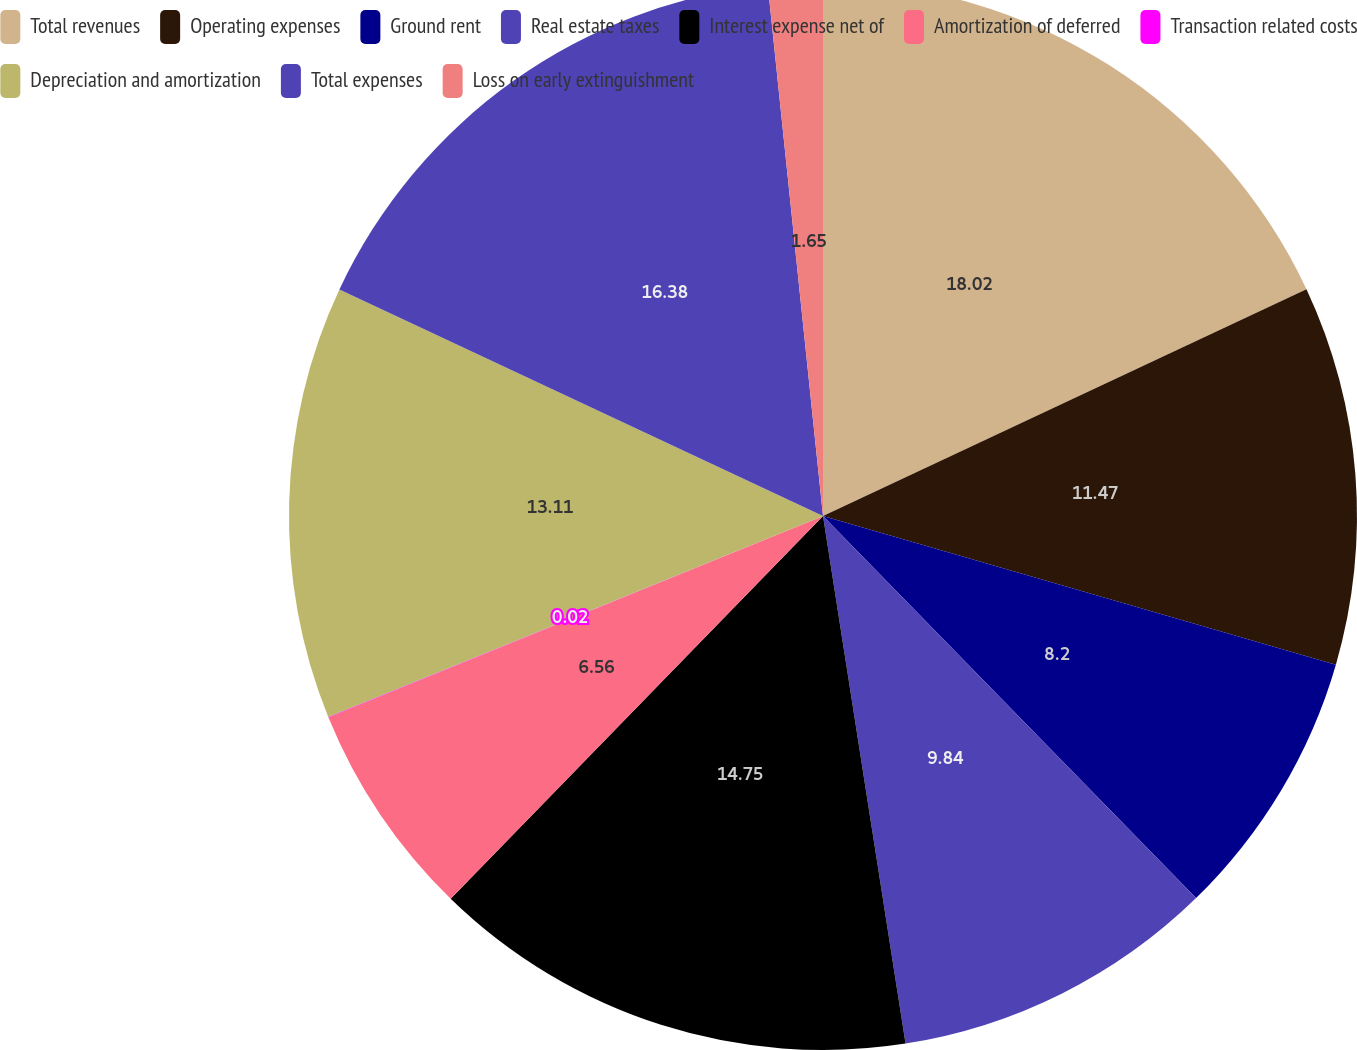Convert chart. <chart><loc_0><loc_0><loc_500><loc_500><pie_chart><fcel>Total revenues<fcel>Operating expenses<fcel>Ground rent<fcel>Real estate taxes<fcel>Interest expense net of<fcel>Amortization of deferred<fcel>Transaction related costs<fcel>Depreciation and amortization<fcel>Total expenses<fcel>Loss on early extinguishment<nl><fcel>18.02%<fcel>11.47%<fcel>8.2%<fcel>9.84%<fcel>14.75%<fcel>6.56%<fcel>0.02%<fcel>13.11%<fcel>16.38%<fcel>1.65%<nl></chart> 